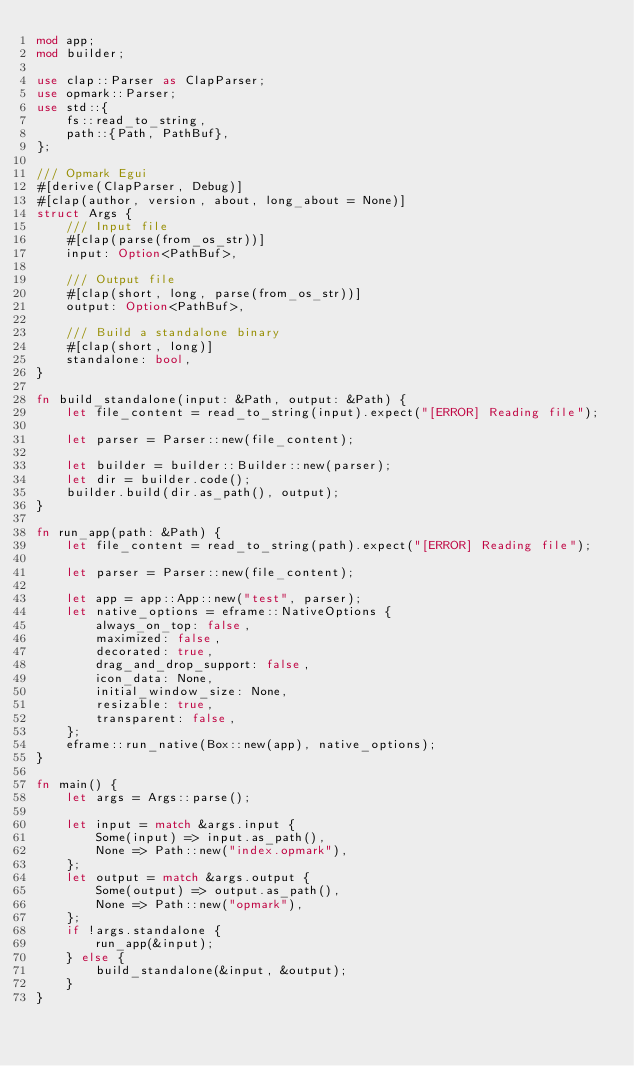<code> <loc_0><loc_0><loc_500><loc_500><_Rust_>mod app;
mod builder;

use clap::Parser as ClapParser;
use opmark::Parser;
use std::{
    fs::read_to_string,
    path::{Path, PathBuf},
};

/// Opmark Egui
#[derive(ClapParser, Debug)]
#[clap(author, version, about, long_about = None)]
struct Args {
    /// Input file
    #[clap(parse(from_os_str))]
    input: Option<PathBuf>,

    /// Output file
    #[clap(short, long, parse(from_os_str))]
    output: Option<PathBuf>,

    /// Build a standalone binary
    #[clap(short, long)]
    standalone: bool,
}

fn build_standalone(input: &Path, output: &Path) {
    let file_content = read_to_string(input).expect("[ERROR] Reading file");

    let parser = Parser::new(file_content);

    let builder = builder::Builder::new(parser);
    let dir = builder.code();
    builder.build(dir.as_path(), output);
}

fn run_app(path: &Path) {
    let file_content = read_to_string(path).expect("[ERROR] Reading file");

    let parser = Parser::new(file_content);

    let app = app::App::new("test", parser);
    let native_options = eframe::NativeOptions {
        always_on_top: false,
        maximized: false,
        decorated: true,
        drag_and_drop_support: false,
        icon_data: None,
        initial_window_size: None,
        resizable: true,
        transparent: false,
    };
    eframe::run_native(Box::new(app), native_options);
}

fn main() {
    let args = Args::parse();

    let input = match &args.input {
        Some(input) => input.as_path(),
        None => Path::new("index.opmark"),
    };
    let output = match &args.output {
        Some(output) => output.as_path(),
        None => Path::new("opmark"),
    };
    if !args.standalone {
        run_app(&input);
    } else {
        build_standalone(&input, &output);
    }
}
</code> 